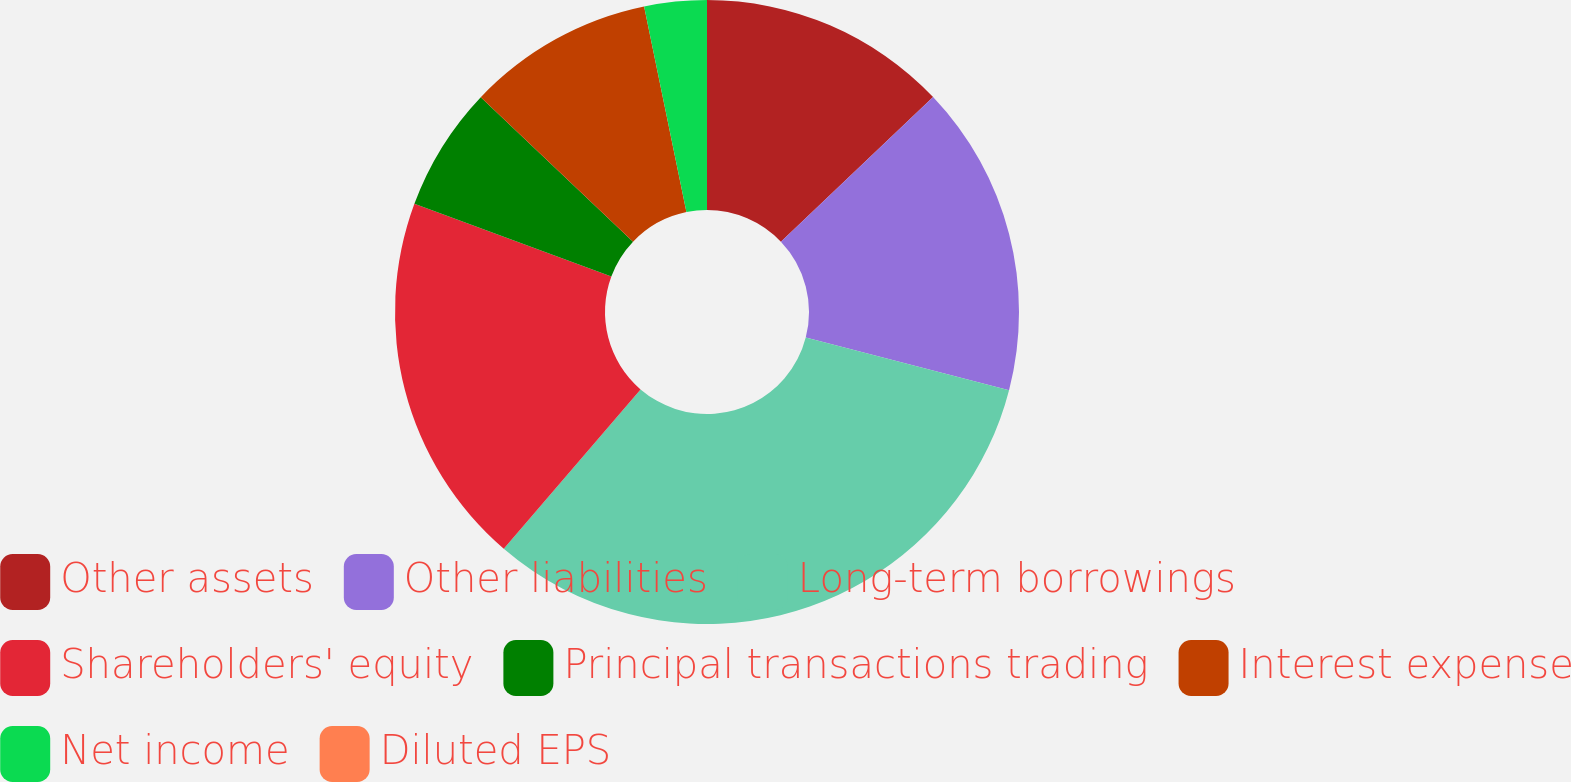Convert chart. <chart><loc_0><loc_0><loc_500><loc_500><pie_chart><fcel>Other assets<fcel>Other liabilities<fcel>Long-term borrowings<fcel>Shareholders' equity<fcel>Principal transactions trading<fcel>Interest expense<fcel>Net income<fcel>Diluted EPS<nl><fcel>12.9%<fcel>16.13%<fcel>32.26%<fcel>19.35%<fcel>6.45%<fcel>9.68%<fcel>3.23%<fcel>0.0%<nl></chart> 